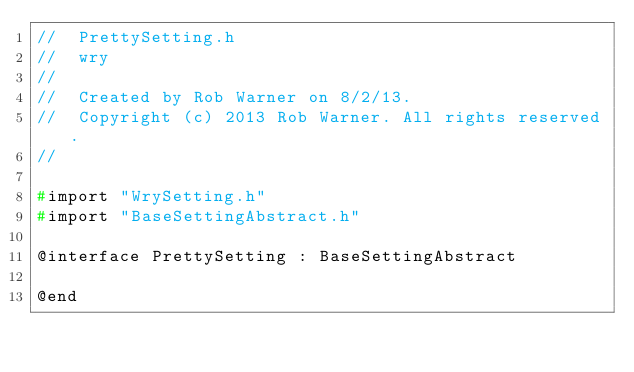Convert code to text. <code><loc_0><loc_0><loc_500><loc_500><_C_>//  PrettySetting.h
//  wry
//
//  Created by Rob Warner on 8/2/13.
//  Copyright (c) 2013 Rob Warner. All rights reserved.
//

#import "WrySetting.h"
#import "BaseSettingAbstract.h"

@interface PrettySetting : BaseSettingAbstract

@end
</code> 